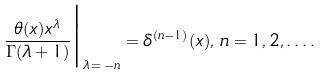<formula> <loc_0><loc_0><loc_500><loc_500>\frac { \theta ( x ) x ^ { \lambda } } { \Gamma ( \lambda + 1 ) } \Big | _ { \lambda \, = \, - n } = \delta ^ { ( n - 1 ) } ( x ) , \, n = 1 , 2 , \dots .</formula> 